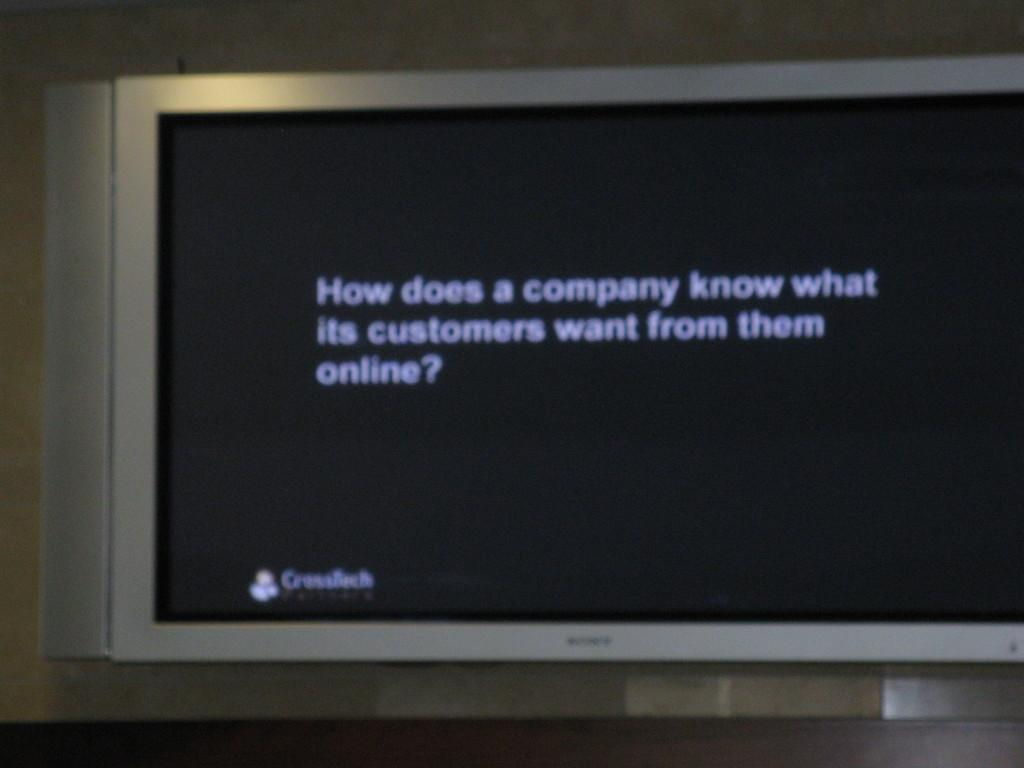<image>
Write a terse but informative summary of the picture. A Sony screen displaying How does a company know what its customers want. 